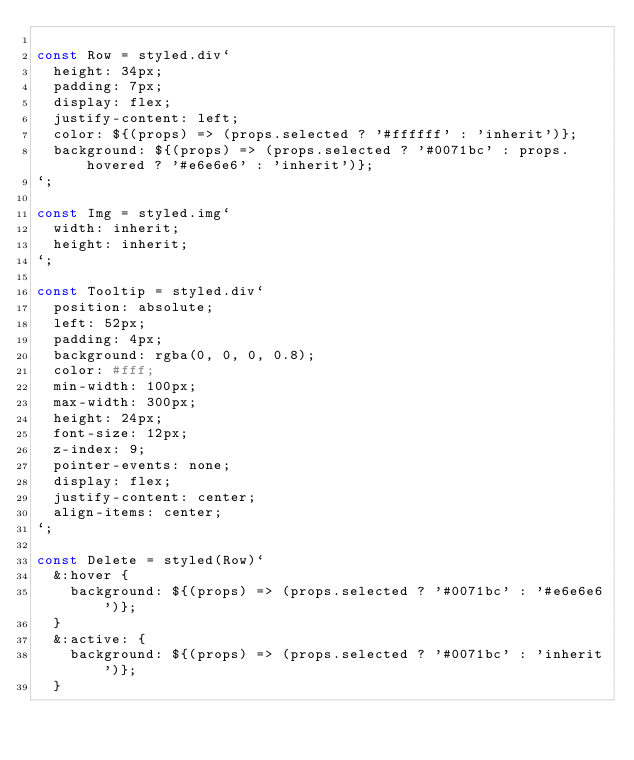Convert code to text. <code><loc_0><loc_0><loc_500><loc_500><_JavaScript_>
const Row = styled.div`
  height: 34px;
  padding: 7px;
  display: flex;
  justify-content: left;
  color: ${(props) => (props.selected ? '#ffffff' : 'inherit')};
  background: ${(props) => (props.selected ? '#0071bc' : props.hovered ? '#e6e6e6' : 'inherit')};
`;

const Img = styled.img`
  width: inherit;
  height: inherit;
`;

const Tooltip = styled.div`
  position: absolute;
  left: 52px;
  padding: 4px;
  background: rgba(0, 0, 0, 0.8);
  color: #fff;
  min-width: 100px;
  max-width: 300px;
  height: 24px;
  font-size: 12px;
  z-index: 9;
  pointer-events: none;
  display: flex;
  justify-content: center;
  align-items: center;
`;

const Delete = styled(Row)`
  &:hover {
    background: ${(props) => (props.selected ? '#0071bc' : '#e6e6e6')};
  }
  &:active: {
    background: ${(props) => (props.selected ? '#0071bc' : 'inherit')};
  }</code> 